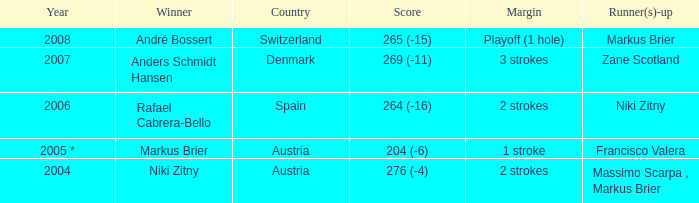When the margin was 1 stroke, who came in second place? Francisco Valera. 